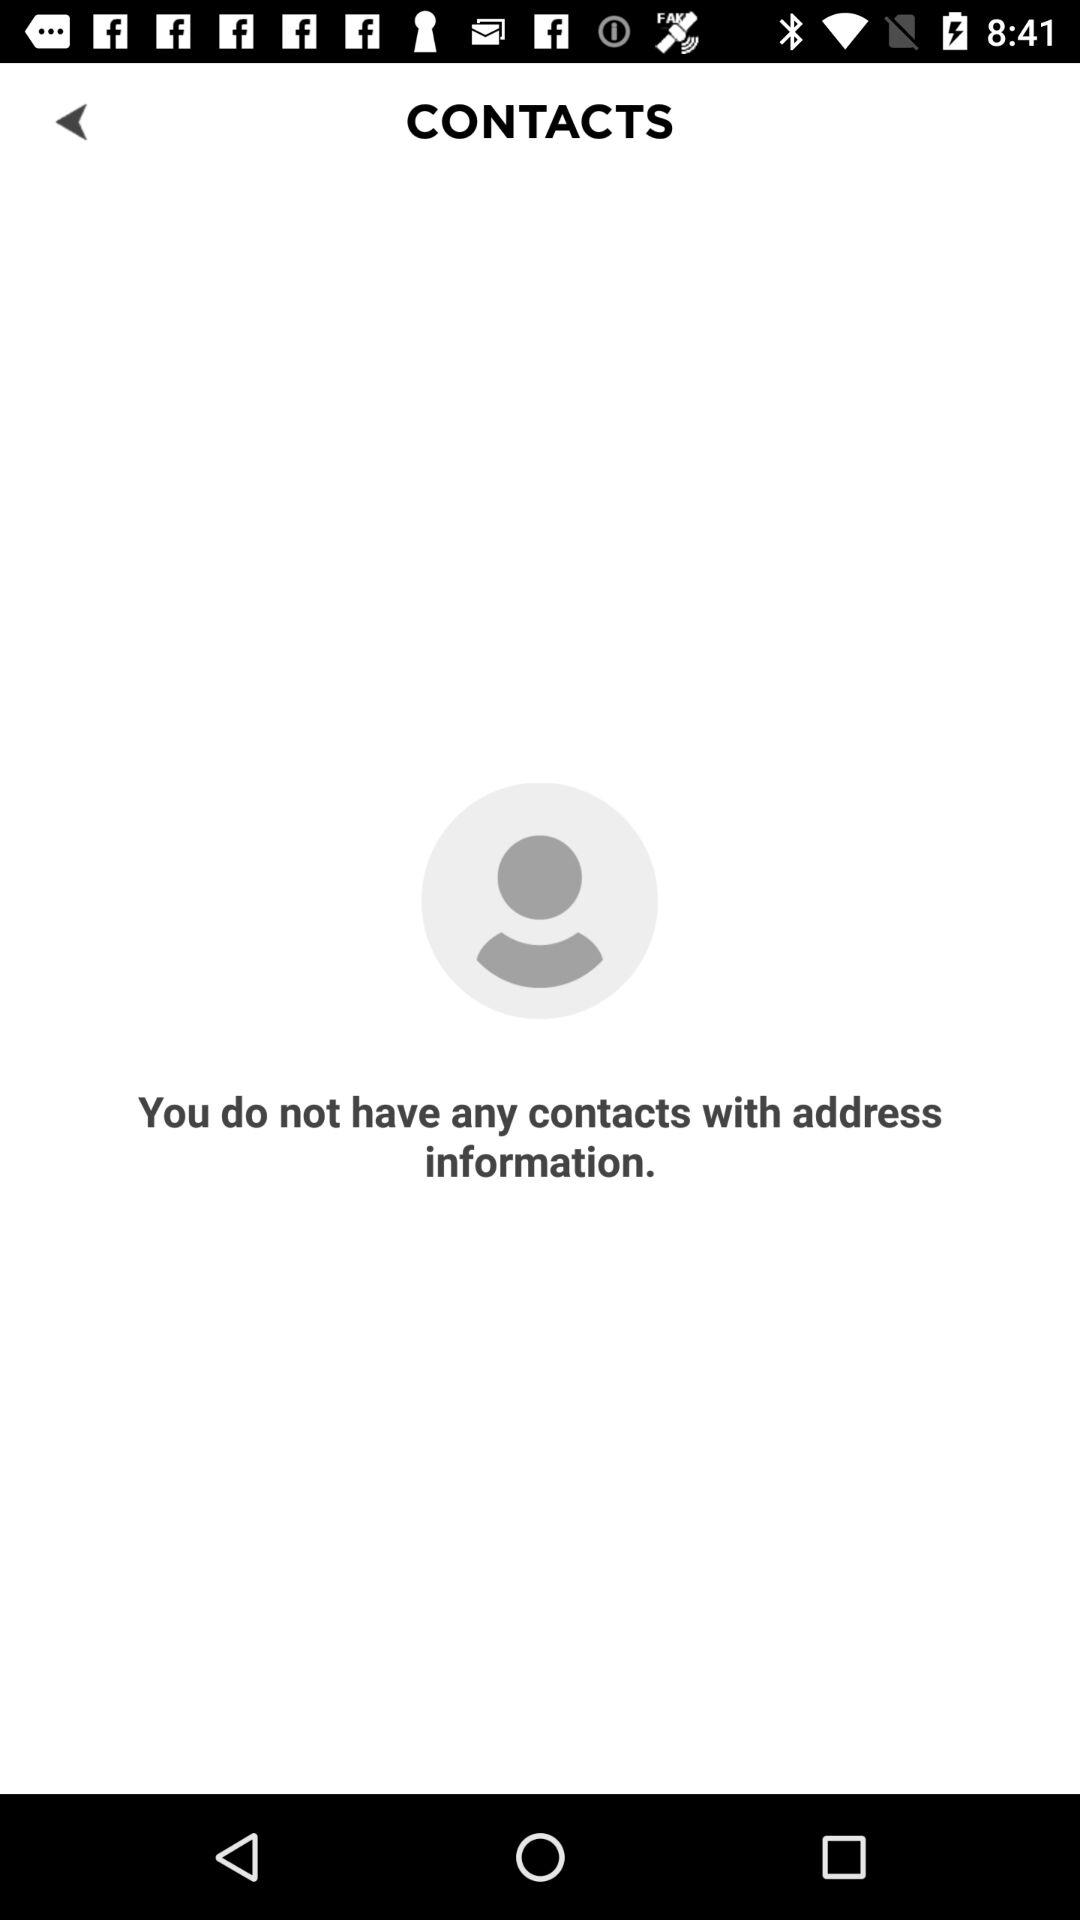How many contacts do I have with address information?
Answer the question using a single word or phrase. 0 